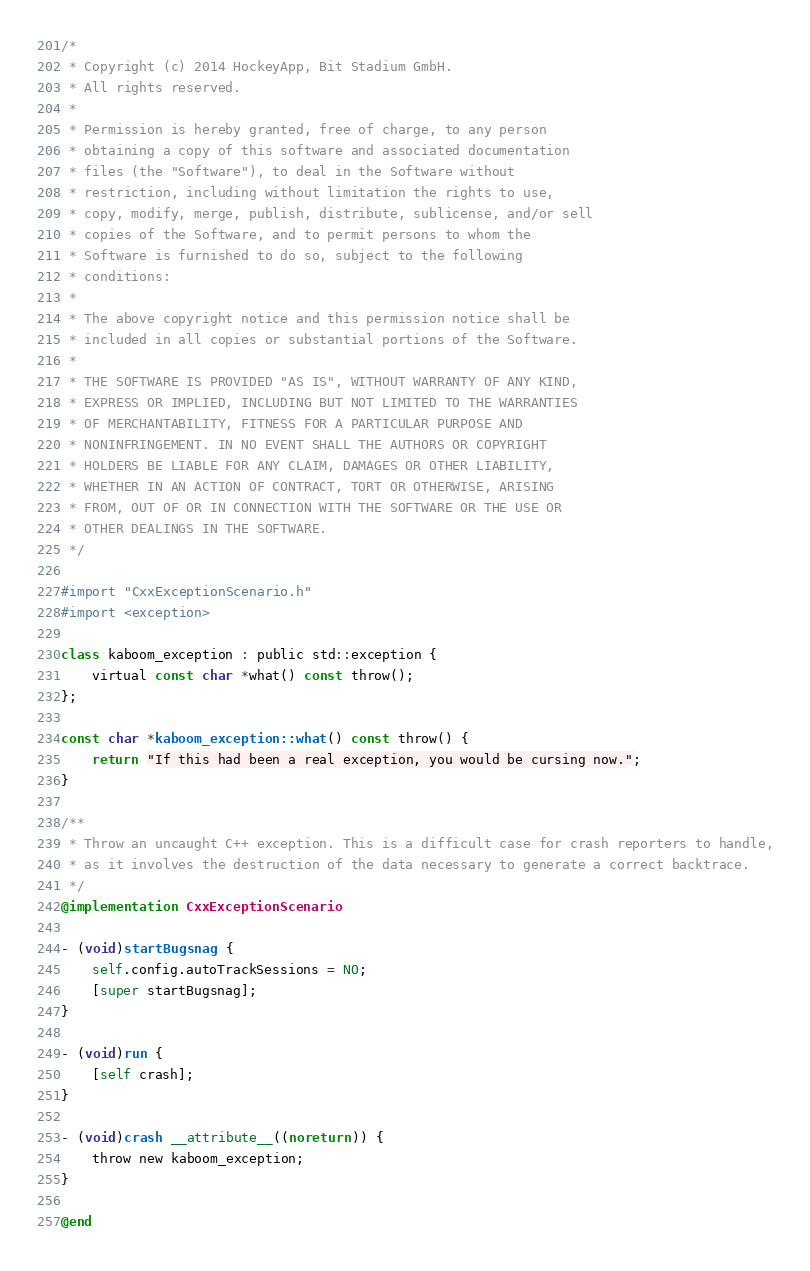Convert code to text. <code><loc_0><loc_0><loc_500><loc_500><_ObjectiveC_>/*
 * Copyright (c) 2014 HockeyApp, Bit Stadium GmbH.
 * All rights reserved.
 *
 * Permission is hereby granted, free of charge, to any person
 * obtaining a copy of this software and associated documentation
 * files (the "Software"), to deal in the Software without
 * restriction, including without limitation the rights to use,
 * copy, modify, merge, publish, distribute, sublicense, and/or sell
 * copies of the Software, and to permit persons to whom the
 * Software is furnished to do so, subject to the following
 * conditions:
 *
 * The above copyright notice and this permission notice shall be
 * included in all copies or substantial portions of the Software.
 *
 * THE SOFTWARE IS PROVIDED "AS IS", WITHOUT WARRANTY OF ANY KIND,
 * EXPRESS OR IMPLIED, INCLUDING BUT NOT LIMITED TO THE WARRANTIES
 * OF MERCHANTABILITY, FITNESS FOR A PARTICULAR PURPOSE AND
 * NONINFRINGEMENT. IN NO EVENT SHALL THE AUTHORS OR COPYRIGHT
 * HOLDERS BE LIABLE FOR ANY CLAIM, DAMAGES OR OTHER LIABILITY,
 * WHETHER IN AN ACTION OF CONTRACT, TORT OR OTHERWISE, ARISING
 * FROM, OUT OF OR IN CONNECTION WITH THE SOFTWARE OR THE USE OR
 * OTHER DEALINGS IN THE SOFTWARE.
 */

#import "CxxExceptionScenario.h"
#import <exception>

class kaboom_exception : public std::exception {
    virtual const char *what() const throw();
};

const char *kaboom_exception::what() const throw() {
    return "If this had been a real exception, you would be cursing now.";
}

/**
 * Throw an uncaught C++ exception. This is a difficult case for crash reporters to handle,
 * as it involves the destruction of the data necessary to generate a correct backtrace.
 */
@implementation CxxExceptionScenario

- (void)startBugsnag {
    self.config.autoTrackSessions = NO;
    [super startBugsnag];
}

- (void)run {
    [self crash];
}

- (void)crash __attribute__((noreturn)) {
    throw new kaboom_exception;
}

@end
</code> 